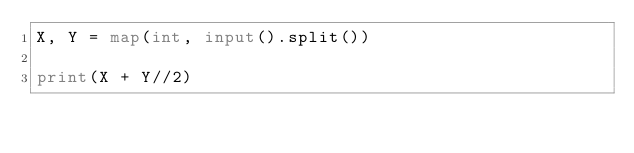Convert code to text. <code><loc_0><loc_0><loc_500><loc_500><_Python_>X, Y = map(int, input().split())

print(X + Y//2)
</code> 